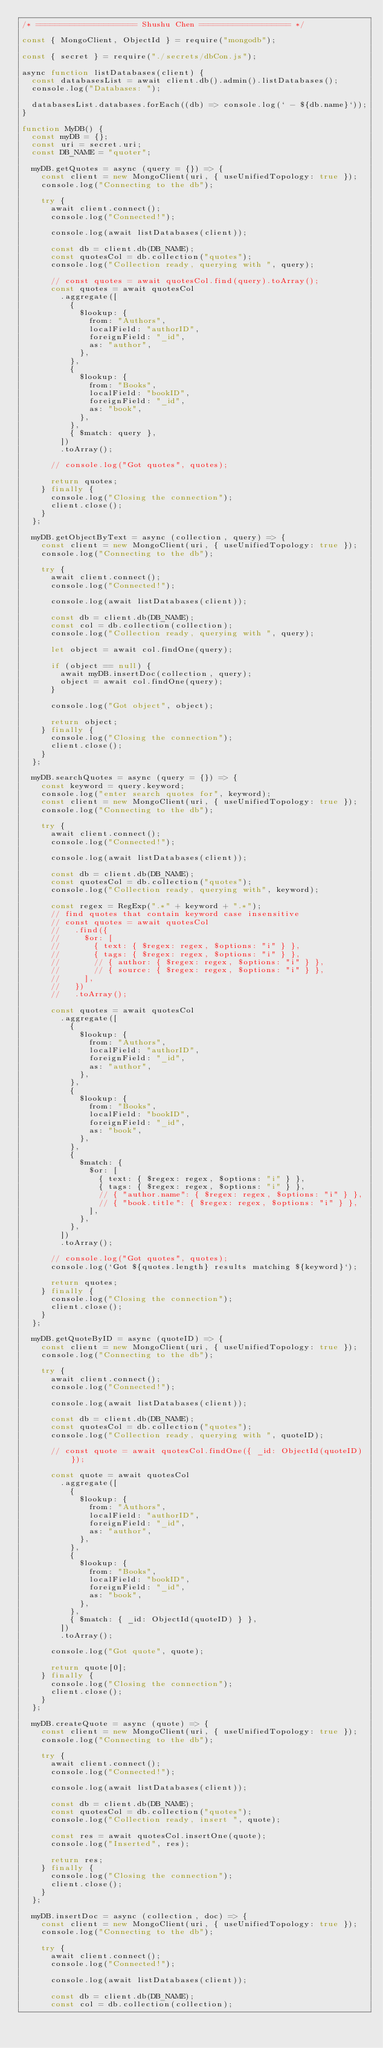<code> <loc_0><loc_0><loc_500><loc_500><_JavaScript_>/* ===================== Shushu Chen =================== */

const { MongoClient, ObjectId } = require("mongodb");

const { secret } = require("./secrets/dbCon.js");

async function listDatabases(client) {
  const databasesList = await client.db().admin().listDatabases();
  console.log("Databases: ");

  databasesList.databases.forEach((db) => console.log(` - ${db.name}`));
}

function MyDB() {
  const myDB = {};
  const uri = secret.uri;
  const DB_NAME = "quoter";

  myDB.getQuotes = async (query = {}) => {
    const client = new MongoClient(uri, { useUnifiedTopology: true });
    console.log("Connecting to the db");

    try {
      await client.connect();
      console.log("Connected!");

      console.log(await listDatabases(client));

      const db = client.db(DB_NAME);
      const quotesCol = db.collection("quotes");
      console.log("Collection ready, querying with ", query);

      // const quotes = await quotesCol.find(query).toArray();
      const quotes = await quotesCol
        .aggregate([
          {
            $lookup: {
              from: "Authors",
              localField: "authorID",
              foreignField: "_id",
              as: "author",
            },
          },
          {
            $lookup: {
              from: "Books",
              localField: "bookID",
              foreignField: "_id",
              as: "book",
            },
          },
          { $match: query },
        ])
        .toArray();

      // console.log("Got quotes", quotes);

      return quotes;
    } finally {
      console.log("Closing the connection");
      client.close();
    }
  };

  myDB.getObjectByText = async (collection, query) => {
    const client = new MongoClient(uri, { useUnifiedTopology: true });
    console.log("Connecting to the db");

    try {
      await client.connect();
      console.log("Connected!");

      console.log(await listDatabases(client));

      const db = client.db(DB_NAME);
      const col = db.collection(collection);
      console.log("Collection ready, querying with ", query);

      let object = await col.findOne(query);

      if (object == null) {
        await myDB.insertDoc(collection, query);
        object = await col.findOne(query);
      }

      console.log("Got object", object);

      return object;
    } finally {
      console.log("Closing the connection");
      client.close();
    }
  };

  myDB.searchQuotes = async (query = {}) => {
    const keyword = query.keyword;
    console.log("enter search quotes for", keyword);
    const client = new MongoClient(uri, { useUnifiedTopology: true });
    console.log("Connecting to the db");

    try {
      await client.connect();
      console.log("Connected!");

      console.log(await listDatabases(client));

      const db = client.db(DB_NAME);
      const quotesCol = db.collection("quotes");
      console.log("Collection ready, querying with", keyword);

      const regex = RegExp(".*" + keyword + ".*");
      // find quotes that contain keyword case insensitive
      // const quotes = await quotesCol
      //   .find({
      //     $or: [
      //       { text: { $regex: regex, $options: "i" } },
      //       { tags: { $regex: regex, $options: "i" } },
      //       // { author: { $regex: regex, $options: "i" } },
      //       // { source: { $regex: regex, $options: "i" } },
      //     ],
      //   })
      //   .toArray();

      const quotes = await quotesCol
        .aggregate([
          {
            $lookup: {
              from: "Authors",
              localField: "authorID",
              foreignField: "_id",
              as: "author",
            },
          },
          {
            $lookup: {
              from: "Books",
              localField: "bookID",
              foreignField: "_id",
              as: "book",
            },
          },
          {
            $match: {
              $or: [
                { text: { $regex: regex, $options: "i" } },
                { tags: { $regex: regex, $options: "i" } },
                // { "author.name": { $regex: regex, $options: "i" } },
                // { "book.title": { $regex: regex, $options: "i" } },
              ],
            },
          },
        ])
        .toArray();

      // console.log("Got quotes", quotes);
      console.log(`Got ${quotes.length} results matching ${keyword}`);

      return quotes;
    } finally {
      console.log("Closing the connection");
      client.close();
    }
  };

  myDB.getQuoteByID = async (quoteID) => {
    const client = new MongoClient(uri, { useUnifiedTopology: true });
    console.log("Connecting to the db");

    try {
      await client.connect();
      console.log("Connected!");

      console.log(await listDatabases(client));

      const db = client.db(DB_NAME);
      const quotesCol = db.collection("quotes");
      console.log("Collection ready, querying with ", quoteID);

      // const quote = await quotesCol.findOne({ _id: ObjectId(quoteID) });

      const quote = await quotesCol
        .aggregate([
          {
            $lookup: {
              from: "Authors",
              localField: "authorID",
              foreignField: "_id",
              as: "author",
            },
          },
          {
            $lookup: {
              from: "Books",
              localField: "bookID",
              foreignField: "_id",
              as: "book",
            },
          },
          { $match: { _id: ObjectId(quoteID) } },
        ])
        .toArray();

      console.log("Got quote", quote);

      return quote[0];
    } finally {
      console.log("Closing the connection");
      client.close();
    }
  };

  myDB.createQuote = async (quote) => {
    const client = new MongoClient(uri, { useUnifiedTopology: true });
    console.log("Connecting to the db");

    try {
      await client.connect();
      console.log("Connected!");

      console.log(await listDatabases(client));

      const db = client.db(DB_NAME);
      const quotesCol = db.collection("quotes");
      console.log("Collection ready, insert ", quote);

      const res = await quotesCol.insertOne(quote);
      console.log("Inserted", res);

      return res;
    } finally {
      console.log("Closing the connection");
      client.close();
    }
  };

  myDB.insertDoc = async (collection, doc) => {
    const client = new MongoClient(uri, { useUnifiedTopology: true });
    console.log("Connecting to the db");

    try {
      await client.connect();
      console.log("Connected!");

      console.log(await listDatabases(client));

      const db = client.db(DB_NAME);
      const col = db.collection(collection);</code> 